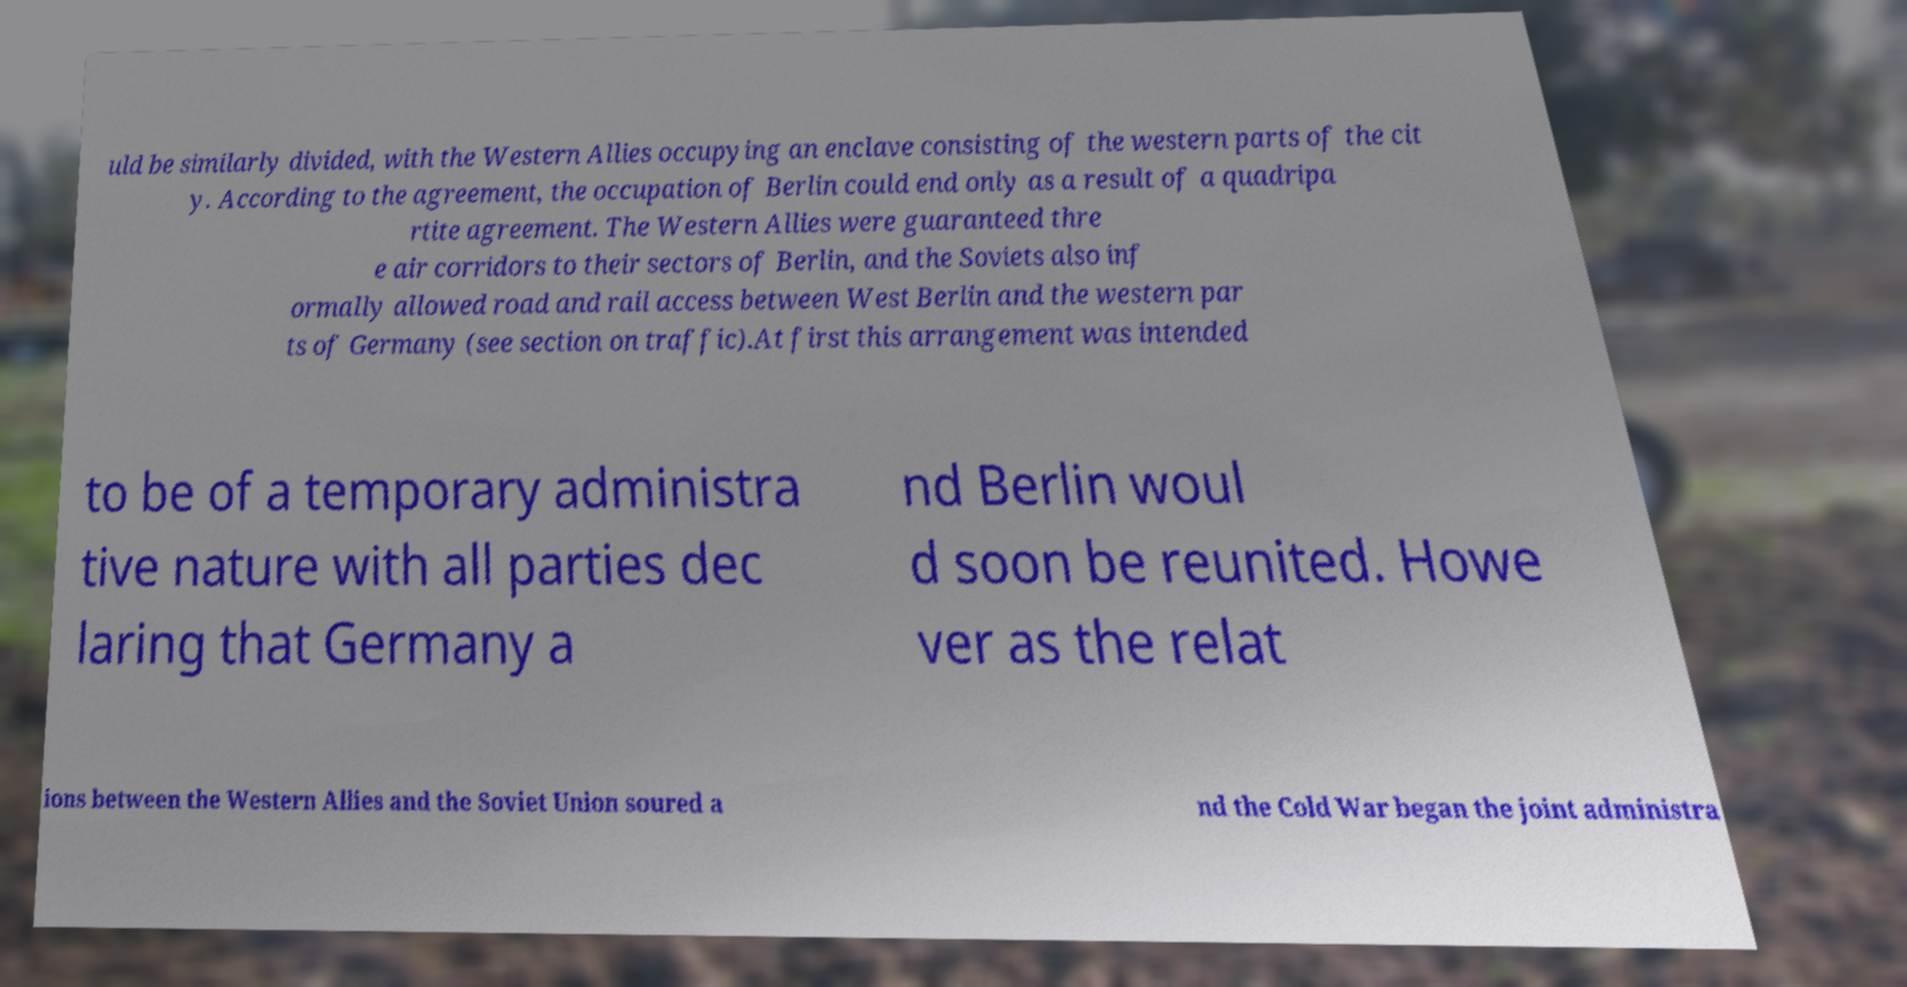I need the written content from this picture converted into text. Can you do that? uld be similarly divided, with the Western Allies occupying an enclave consisting of the western parts of the cit y. According to the agreement, the occupation of Berlin could end only as a result of a quadripa rtite agreement. The Western Allies were guaranteed thre e air corridors to their sectors of Berlin, and the Soviets also inf ormally allowed road and rail access between West Berlin and the western par ts of Germany (see section on traffic).At first this arrangement was intended to be of a temporary administra tive nature with all parties dec laring that Germany a nd Berlin woul d soon be reunited. Howe ver as the relat ions between the Western Allies and the Soviet Union soured a nd the Cold War began the joint administra 